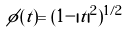Convert formula to latex. <formula><loc_0><loc_0><loc_500><loc_500>\phi ( t ) = ( 1 - | t | ^ { 2 } ) ^ { 1 / 2 } \</formula> 